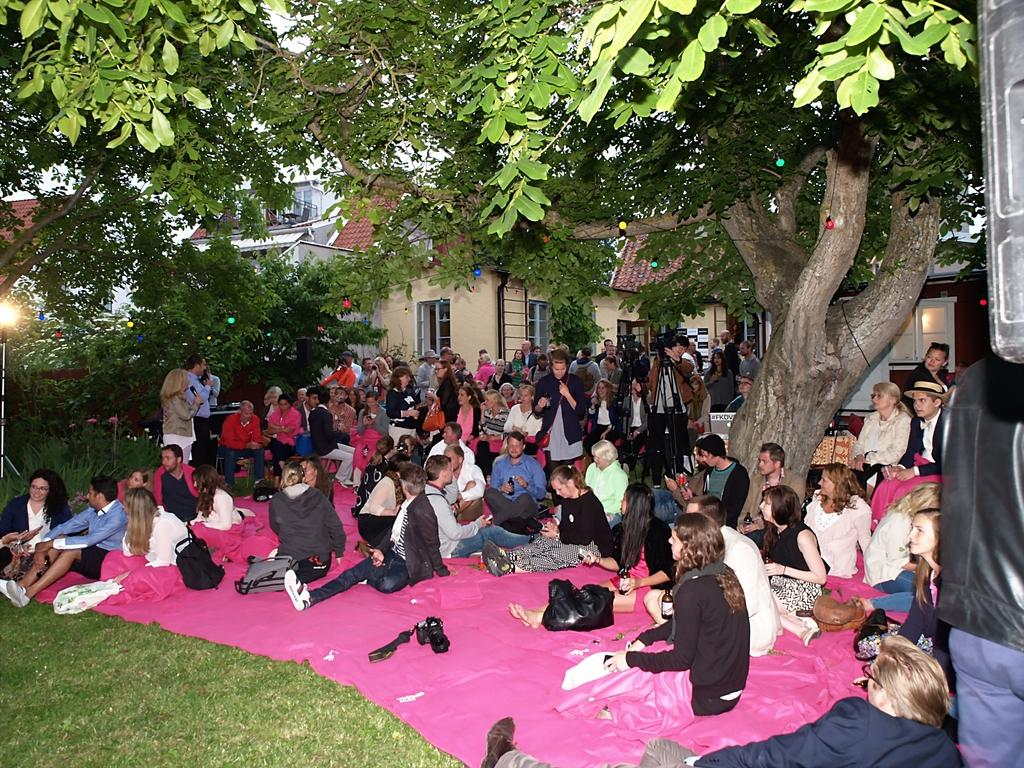What are the people in the image doing? The people in the image are sitting in the garden. What type of vegetation can be seen in the image? There are trees in the image. What equipment is visible in the image? There is a camera stand in the image. What type of structures can be seen in the image? There are houses in the image. How many cats are sitting on the people's laps in the image? There are no cats present in the image. What type of underwear is the person wearing in the image? There is no information about the people's clothing in the image, so it cannot be determined. 